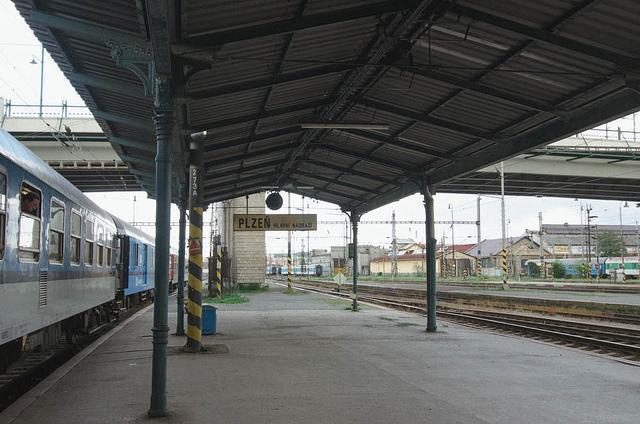How many zebras are in this photo?
Give a very brief answer. 0. 